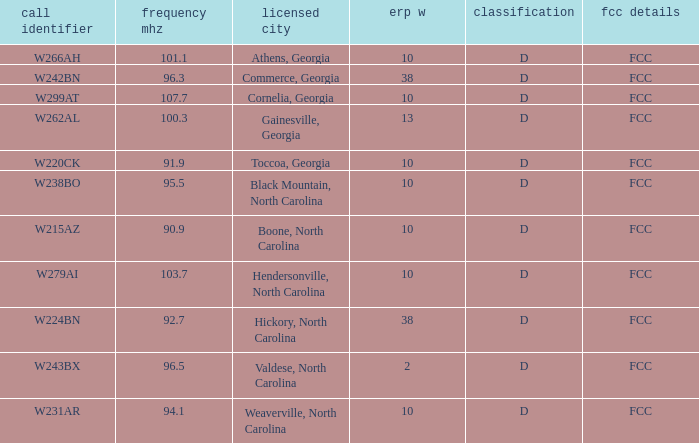What is the mhz frequency for the station with a call sign of w224bn? 92.7. 